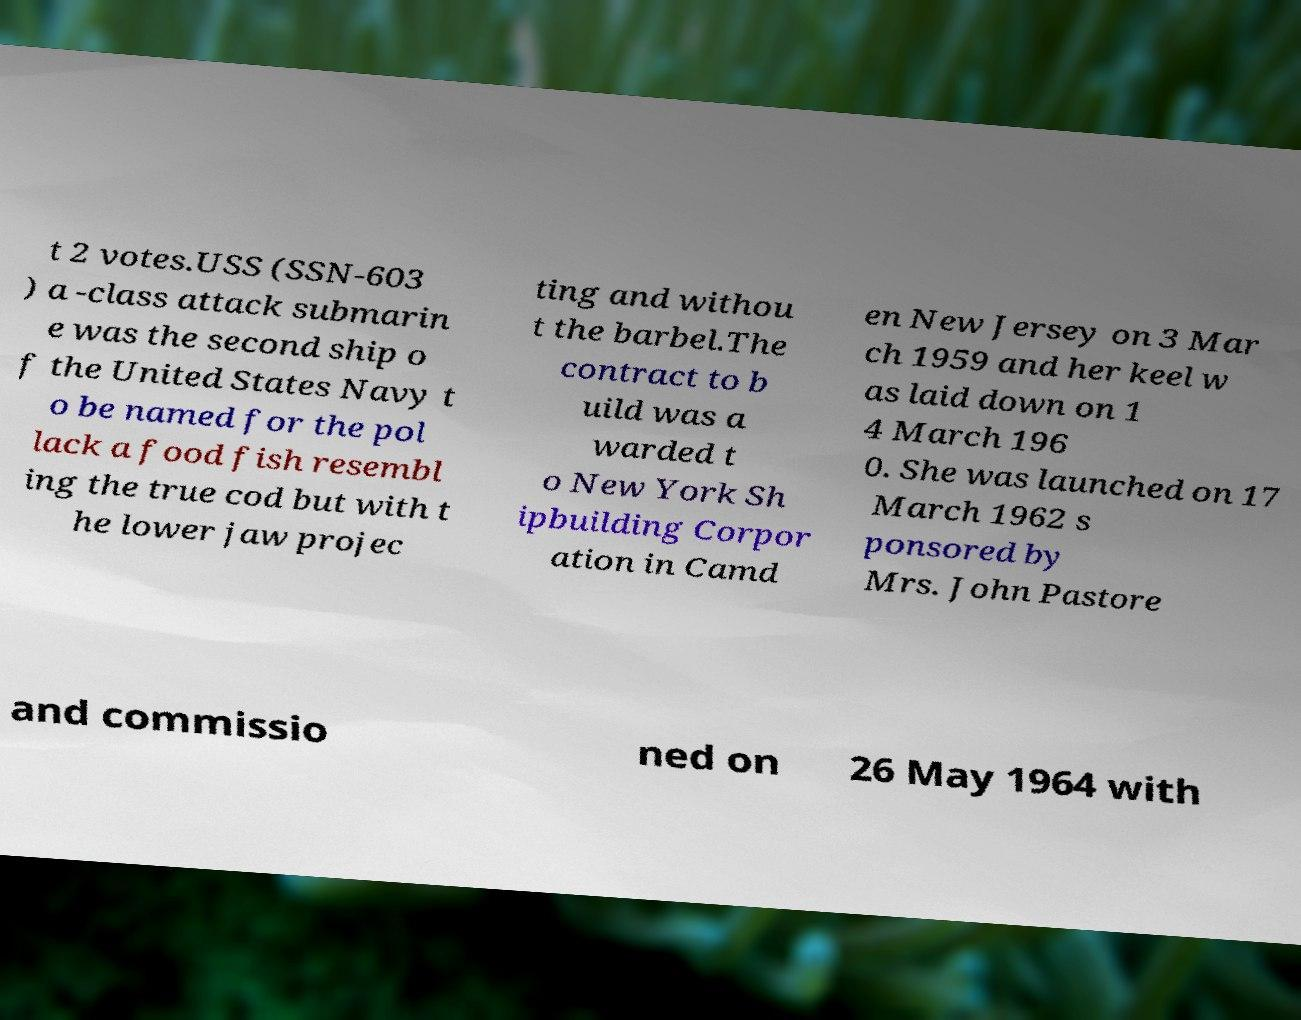Can you accurately transcribe the text from the provided image for me? t 2 votes.USS (SSN-603 ) a -class attack submarin e was the second ship o f the United States Navy t o be named for the pol lack a food fish resembl ing the true cod but with t he lower jaw projec ting and withou t the barbel.The contract to b uild was a warded t o New York Sh ipbuilding Corpor ation in Camd en New Jersey on 3 Mar ch 1959 and her keel w as laid down on 1 4 March 196 0. She was launched on 17 March 1962 s ponsored by Mrs. John Pastore and commissio ned on 26 May 1964 with 